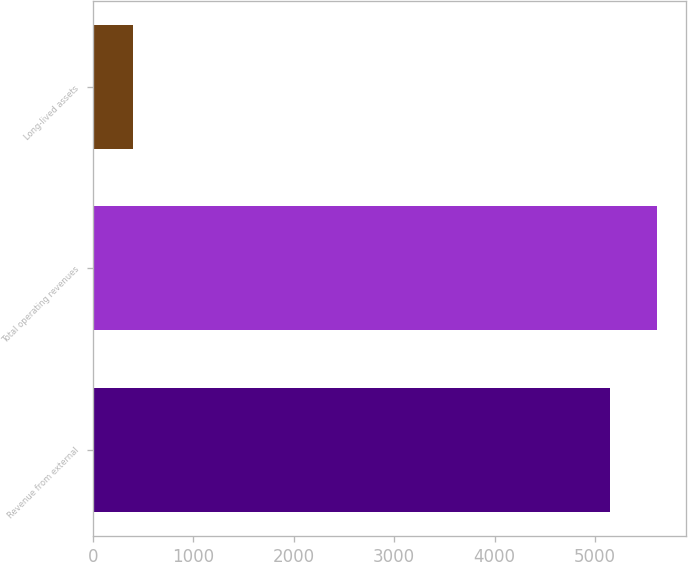Convert chart. <chart><loc_0><loc_0><loc_500><loc_500><bar_chart><fcel>Revenue from external<fcel>Total operating revenues<fcel>Long-lived assets<nl><fcel>5147.1<fcel>5621.55<fcel>402.6<nl></chart> 